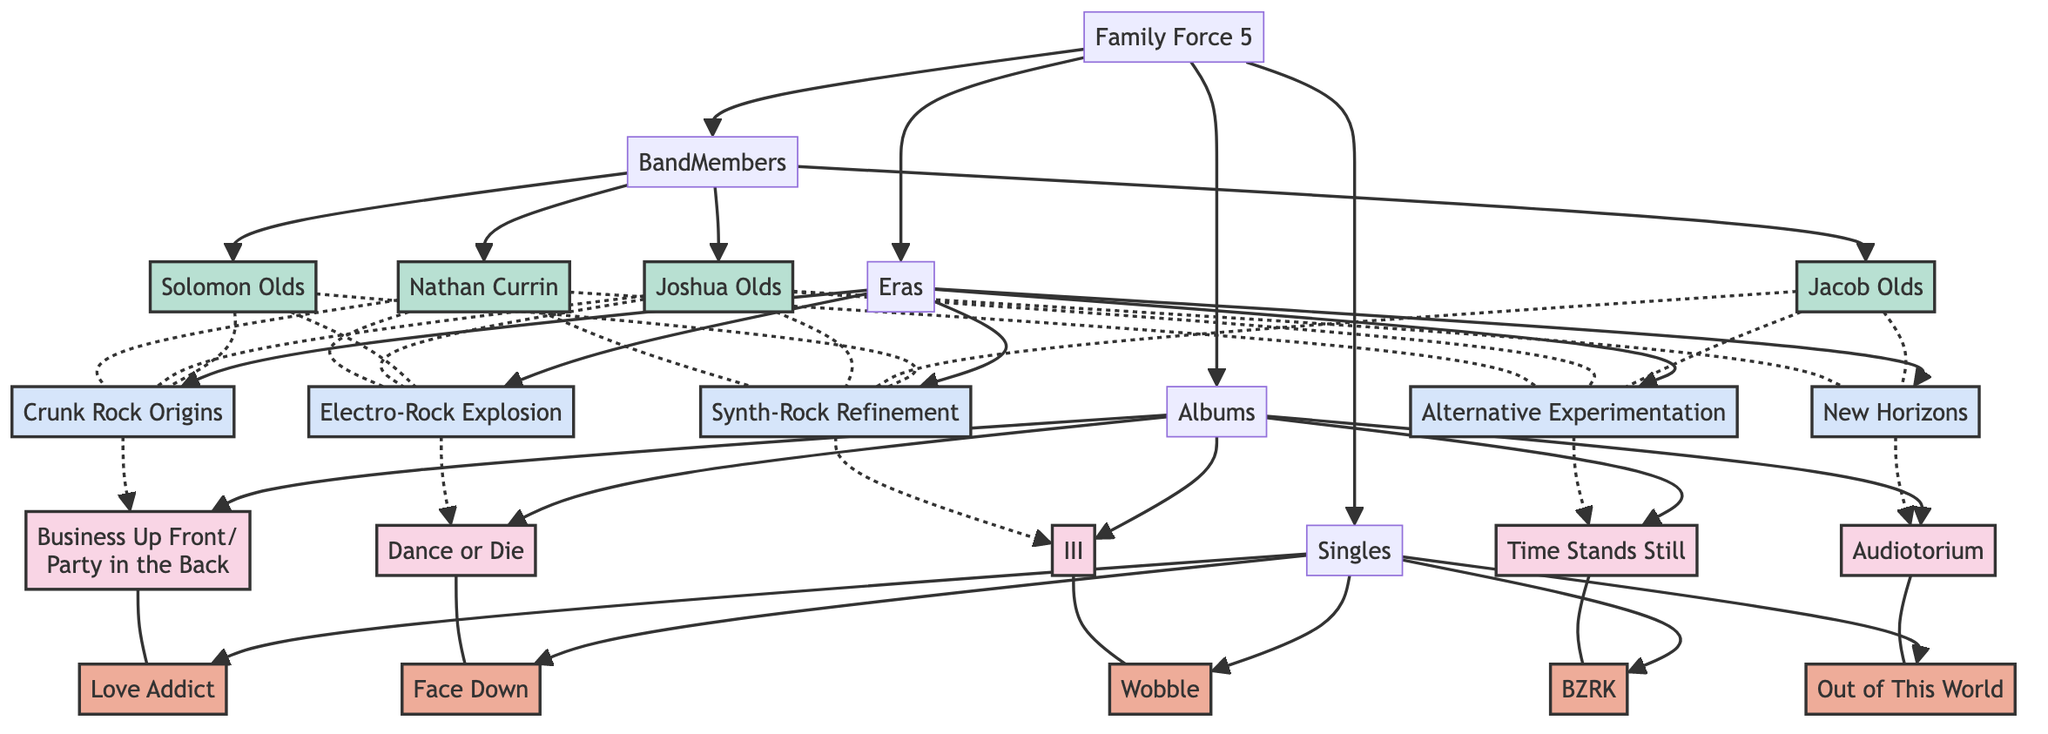What is the first album released by Family Force 5? The diagram shows "Business Up Front/Party in the Back" connected to the Albums node, indicating it is the first album released.
Answer: Business Up Front/Party in the Back How many singles are listed in the diagram? Counting the nodes under the Singles section shows a total of five singles connected to the Singles node.
Answer: 5 Which era is defined as "Crunk Rock Origins"? The diagram connects the label "Crunk Rock Origins" to the Eras section, indicating that this is the correct label for that era.
Answer: Crunk Rock Origins Who was the vocalist and drummer from 2004 to 2013? The diagram indicates that Solomon Olds is connected to the Band Members section with the role of vocalist and drummer, specifying the active years from 2004 to 2013.
Answer: Solomon Olds What style is associated with the album "Time Stands Still"? The diagram links "Time Stands Still" to the style of Alternative Rock, providing the information on the associated music style.
Answer: Alternative Rock Which singles are connected to the album "III"? The diagram shows "Wobble" linked directly to the album "III," indicating that it is the single associated with that album.
Answer: Wobble During which era did Family Force 5 transition to an electronic sound? From the Eras section, we see that "Electro-Rock Explosion" covers the years 2008 to 2011, correlating with their transition to an electronic sound.
Answer: Electro-Rock Explosion How many band members are active in the current era? Referring to the band members' timelines reveals that Jacob Olds, Joshua Olds, and the always-active Nathan Currin are the members listed under current active years, equating to three members.
Answer: 3 What is the label that released the album "Audiotorium"? The diagram directly connects "Audiotorium" to the label category, showing that it is an Independent release.
Answer: Independent 